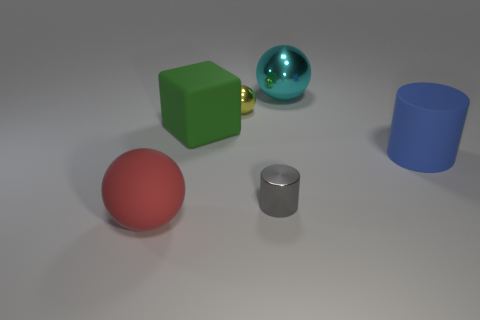Which object in this image would roll if pushed? The sphere and the cylinder would roll if pushed, due to their rounded surfaces. The sphere, with its fully round shape, can roll in any direction, while the cylinder would roll in the direction perpendicular to its circular bases. 